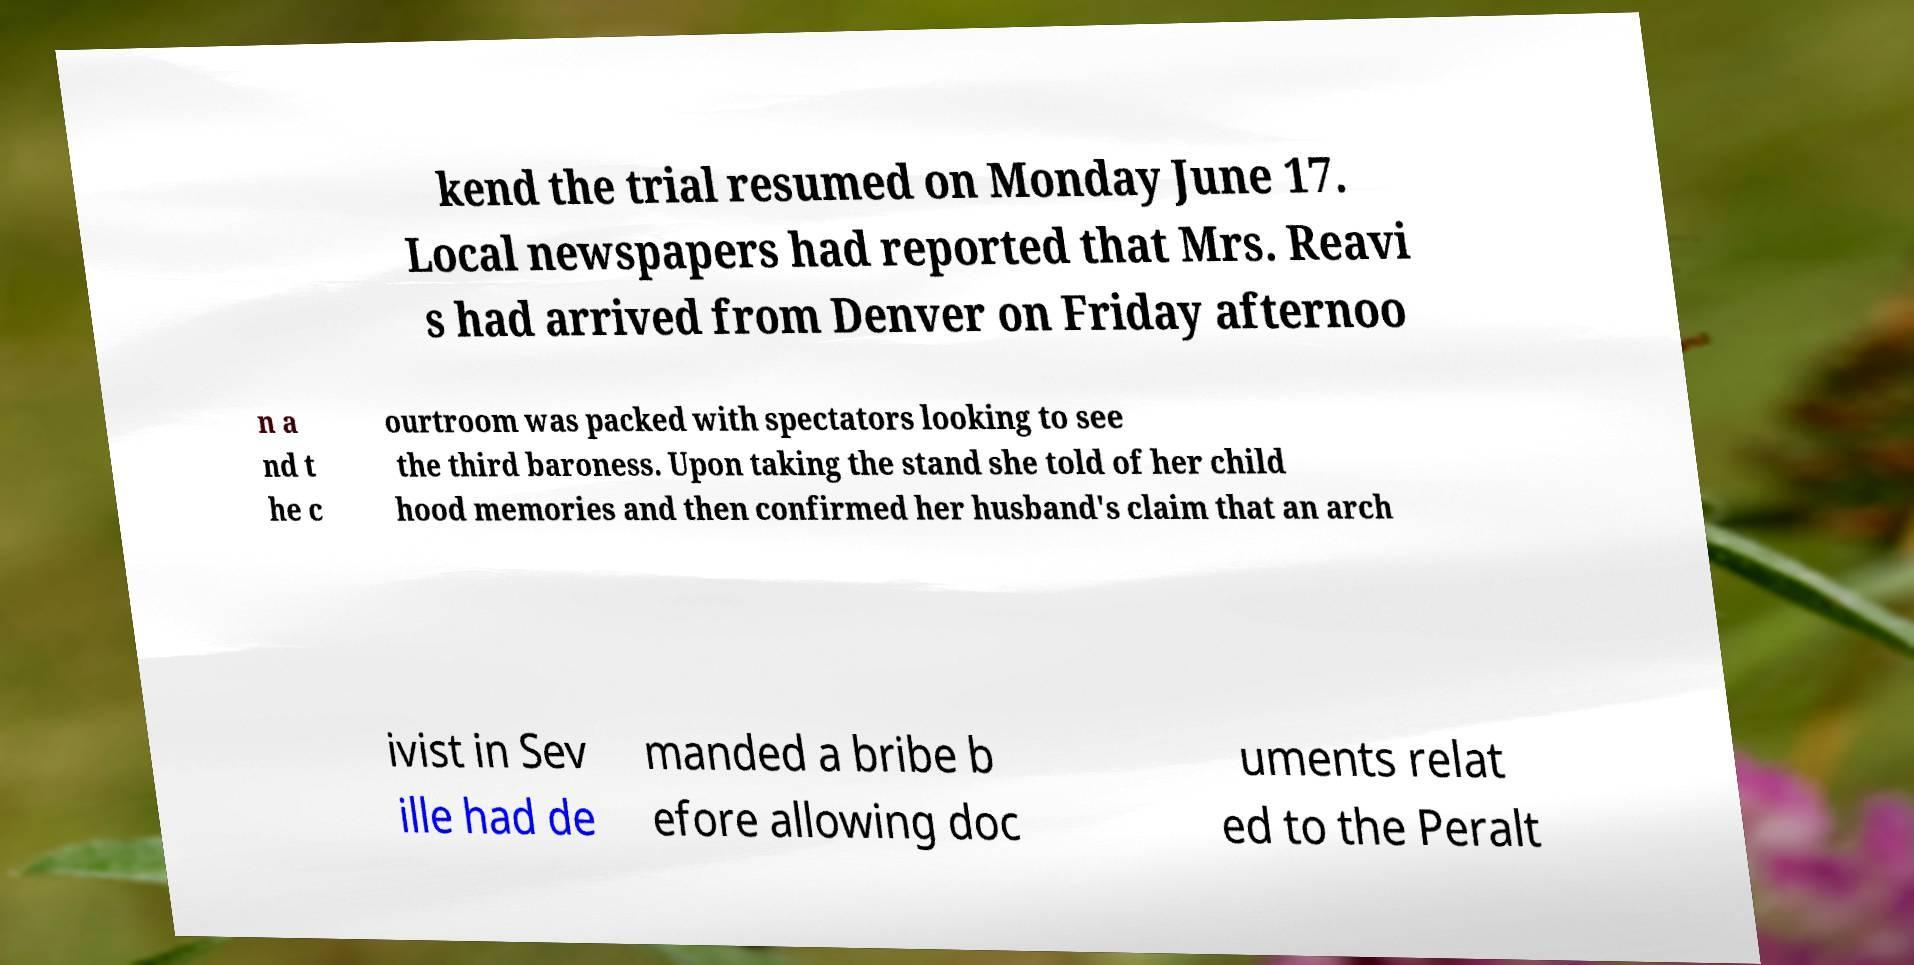Please identify and transcribe the text found in this image. kend the trial resumed on Monday June 17. Local newspapers had reported that Mrs. Reavi s had arrived from Denver on Friday afternoo n a nd t he c ourtroom was packed with spectators looking to see the third baroness. Upon taking the stand she told of her child hood memories and then confirmed her husband's claim that an arch ivist in Sev ille had de manded a bribe b efore allowing doc uments relat ed to the Peralt 